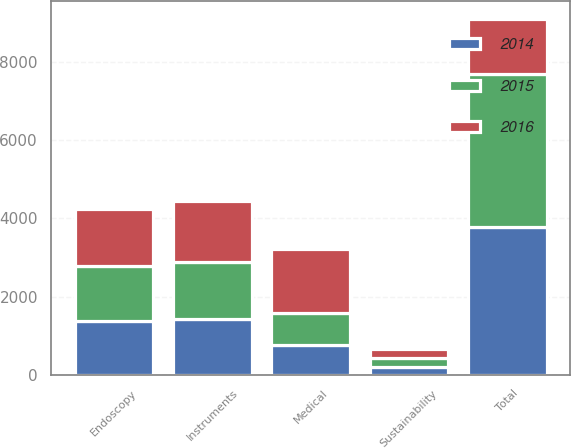Convert chart. <chart><loc_0><loc_0><loc_500><loc_500><stacked_bar_chart><ecel><fcel>Instruments<fcel>Endoscopy<fcel>Medical<fcel>Sustainability<fcel>Total<nl><fcel>2016<fcel>1553<fcel>1470<fcel>1633<fcel>238<fcel>1407<nl><fcel>2015<fcel>1466<fcel>1390<fcel>823<fcel>216<fcel>3895<nl><fcel>2014<fcel>1424<fcel>1382<fcel>766<fcel>209<fcel>3781<nl></chart> 